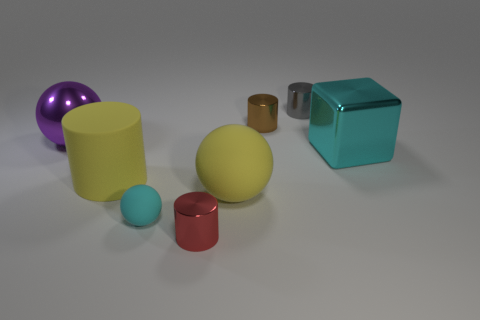Is the size of the gray metal thing the same as the yellow rubber cylinder that is behind the tiny cyan sphere?
Provide a succinct answer. No. Are there any other large shiny cubes that have the same color as the large block?
Give a very brief answer. No. Is the material of the small gray cylinder the same as the red cylinder?
Your answer should be compact. Yes. There is a large cyan metallic block; how many small cylinders are on the right side of it?
Ensure brevity in your answer.  0. The large thing that is both right of the large yellow cylinder and behind the large yellow sphere is made of what material?
Your response must be concise. Metal. What number of other red objects have the same size as the red metallic object?
Keep it short and to the point. 0. What color is the tiny shiny cylinder in front of the big thing left of the yellow rubber cylinder?
Your answer should be very brief. Red. Are there any large green metal objects?
Keep it short and to the point. No. Do the cyan rubber thing and the small red thing have the same shape?
Your response must be concise. No. What size is the rubber object that is the same color as the big matte sphere?
Make the answer very short. Large. 